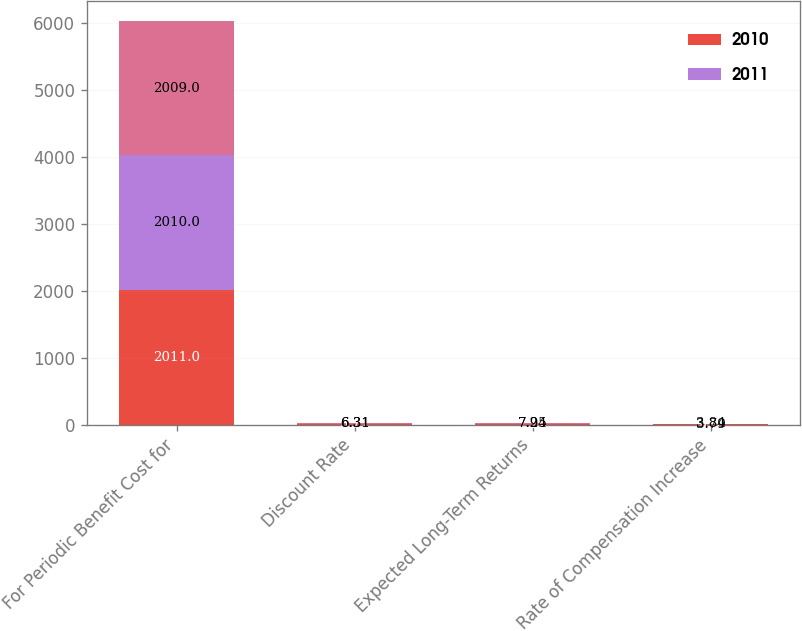Convert chart. <chart><loc_0><loc_0><loc_500><loc_500><stacked_bar_chart><ecel><fcel>For Periodic Benefit Cost for<fcel>Discount Rate<fcel>Expected Long-Term Returns<fcel>Rate of Compensation Increase<nl><fcel>2010<fcel>2011<fcel>5.77<fcel>7.24<fcel>4<nl><fcel>2011<fcel>2010<fcel>6.31<fcel>7.24<fcel>3.79<nl><fcel>nan<fcel>2009<fcel>6.31<fcel>7.95<fcel>3.84<nl></chart> 